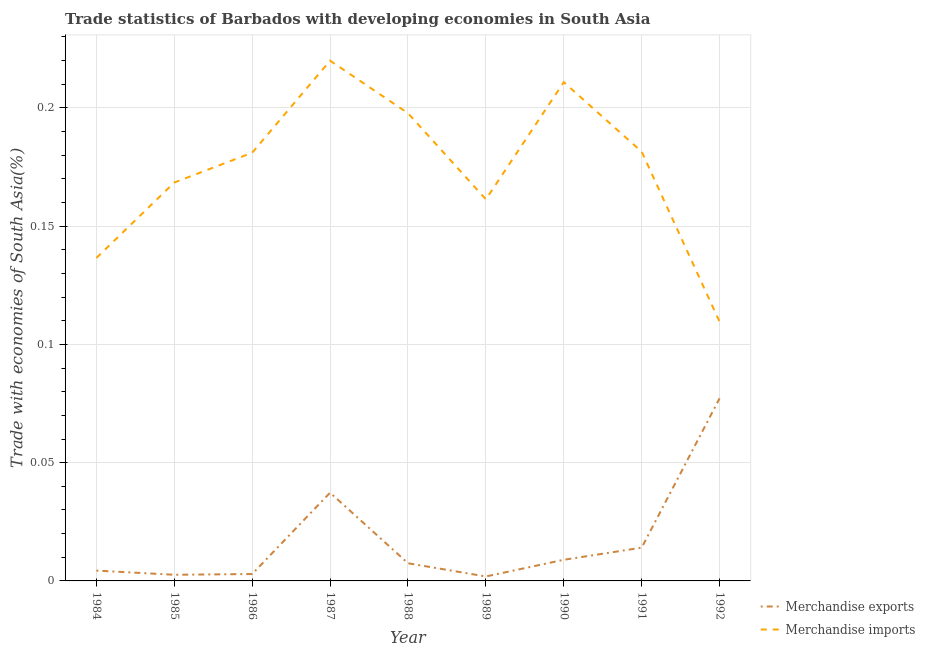How many different coloured lines are there?
Give a very brief answer. 2. Does the line corresponding to merchandise exports intersect with the line corresponding to merchandise imports?
Provide a succinct answer. No. What is the merchandise exports in 1992?
Provide a short and direct response. 0.08. Across all years, what is the maximum merchandise exports?
Make the answer very short. 0.08. Across all years, what is the minimum merchandise exports?
Ensure brevity in your answer.  0. In which year was the merchandise exports maximum?
Ensure brevity in your answer.  1992. In which year was the merchandise exports minimum?
Your answer should be compact. 1989. What is the total merchandise exports in the graph?
Offer a terse response. 0.16. What is the difference between the merchandise imports in 1984 and that in 1988?
Give a very brief answer. -0.06. What is the difference between the merchandise exports in 1991 and the merchandise imports in 1989?
Make the answer very short. -0.15. What is the average merchandise exports per year?
Provide a succinct answer. 0.02. In the year 1992, what is the difference between the merchandise imports and merchandise exports?
Keep it short and to the point. 0.03. What is the ratio of the merchandise exports in 1986 to that in 1990?
Provide a succinct answer. 0.33. Is the merchandise imports in 1985 less than that in 1991?
Offer a terse response. Yes. What is the difference between the highest and the second highest merchandise exports?
Keep it short and to the point. 0.04. What is the difference between the highest and the lowest merchandise exports?
Make the answer very short. 0.08. Is the sum of the merchandise imports in 1984 and 1985 greater than the maximum merchandise exports across all years?
Keep it short and to the point. Yes. Is the merchandise imports strictly greater than the merchandise exports over the years?
Provide a short and direct response. Yes. Is the merchandise exports strictly less than the merchandise imports over the years?
Your response must be concise. Yes. Are the values on the major ticks of Y-axis written in scientific E-notation?
Give a very brief answer. No. Does the graph contain any zero values?
Give a very brief answer. No. Does the graph contain grids?
Make the answer very short. Yes. Where does the legend appear in the graph?
Provide a short and direct response. Bottom right. How are the legend labels stacked?
Offer a terse response. Vertical. What is the title of the graph?
Provide a succinct answer. Trade statistics of Barbados with developing economies in South Asia. What is the label or title of the Y-axis?
Offer a very short reply. Trade with economies of South Asia(%). What is the Trade with economies of South Asia(%) in Merchandise exports in 1984?
Keep it short and to the point. 0. What is the Trade with economies of South Asia(%) in Merchandise imports in 1984?
Ensure brevity in your answer.  0.14. What is the Trade with economies of South Asia(%) in Merchandise exports in 1985?
Your answer should be compact. 0. What is the Trade with economies of South Asia(%) of Merchandise imports in 1985?
Your answer should be very brief. 0.17. What is the Trade with economies of South Asia(%) in Merchandise exports in 1986?
Offer a terse response. 0. What is the Trade with economies of South Asia(%) of Merchandise imports in 1986?
Offer a terse response. 0.18. What is the Trade with economies of South Asia(%) in Merchandise exports in 1987?
Your answer should be very brief. 0.04. What is the Trade with economies of South Asia(%) in Merchandise imports in 1987?
Ensure brevity in your answer.  0.22. What is the Trade with economies of South Asia(%) in Merchandise exports in 1988?
Provide a short and direct response. 0.01. What is the Trade with economies of South Asia(%) in Merchandise imports in 1988?
Keep it short and to the point. 0.2. What is the Trade with economies of South Asia(%) of Merchandise exports in 1989?
Offer a very short reply. 0. What is the Trade with economies of South Asia(%) of Merchandise imports in 1989?
Ensure brevity in your answer.  0.16. What is the Trade with economies of South Asia(%) of Merchandise exports in 1990?
Offer a very short reply. 0.01. What is the Trade with economies of South Asia(%) in Merchandise imports in 1990?
Offer a terse response. 0.21. What is the Trade with economies of South Asia(%) of Merchandise exports in 1991?
Provide a succinct answer. 0.01. What is the Trade with economies of South Asia(%) of Merchandise imports in 1991?
Keep it short and to the point. 0.18. What is the Trade with economies of South Asia(%) in Merchandise exports in 1992?
Your answer should be very brief. 0.08. What is the Trade with economies of South Asia(%) of Merchandise imports in 1992?
Give a very brief answer. 0.11. Across all years, what is the maximum Trade with economies of South Asia(%) in Merchandise exports?
Offer a terse response. 0.08. Across all years, what is the maximum Trade with economies of South Asia(%) in Merchandise imports?
Your answer should be compact. 0.22. Across all years, what is the minimum Trade with economies of South Asia(%) in Merchandise exports?
Offer a terse response. 0. Across all years, what is the minimum Trade with economies of South Asia(%) of Merchandise imports?
Your answer should be compact. 0.11. What is the total Trade with economies of South Asia(%) of Merchandise exports in the graph?
Keep it short and to the point. 0.16. What is the total Trade with economies of South Asia(%) of Merchandise imports in the graph?
Provide a succinct answer. 1.57. What is the difference between the Trade with economies of South Asia(%) in Merchandise exports in 1984 and that in 1985?
Ensure brevity in your answer.  0. What is the difference between the Trade with economies of South Asia(%) of Merchandise imports in 1984 and that in 1985?
Your answer should be compact. -0.03. What is the difference between the Trade with economies of South Asia(%) in Merchandise exports in 1984 and that in 1986?
Provide a succinct answer. 0. What is the difference between the Trade with economies of South Asia(%) of Merchandise imports in 1984 and that in 1986?
Your answer should be very brief. -0.04. What is the difference between the Trade with economies of South Asia(%) in Merchandise exports in 1984 and that in 1987?
Keep it short and to the point. -0.03. What is the difference between the Trade with economies of South Asia(%) of Merchandise imports in 1984 and that in 1987?
Make the answer very short. -0.08. What is the difference between the Trade with economies of South Asia(%) of Merchandise exports in 1984 and that in 1988?
Your response must be concise. -0. What is the difference between the Trade with economies of South Asia(%) in Merchandise imports in 1984 and that in 1988?
Offer a very short reply. -0.06. What is the difference between the Trade with economies of South Asia(%) of Merchandise exports in 1984 and that in 1989?
Your response must be concise. 0. What is the difference between the Trade with economies of South Asia(%) in Merchandise imports in 1984 and that in 1989?
Ensure brevity in your answer.  -0.02. What is the difference between the Trade with economies of South Asia(%) in Merchandise exports in 1984 and that in 1990?
Provide a short and direct response. -0. What is the difference between the Trade with economies of South Asia(%) in Merchandise imports in 1984 and that in 1990?
Offer a terse response. -0.07. What is the difference between the Trade with economies of South Asia(%) of Merchandise exports in 1984 and that in 1991?
Give a very brief answer. -0.01. What is the difference between the Trade with economies of South Asia(%) of Merchandise imports in 1984 and that in 1991?
Give a very brief answer. -0.04. What is the difference between the Trade with economies of South Asia(%) of Merchandise exports in 1984 and that in 1992?
Offer a terse response. -0.07. What is the difference between the Trade with economies of South Asia(%) in Merchandise imports in 1984 and that in 1992?
Your answer should be very brief. 0.03. What is the difference between the Trade with economies of South Asia(%) in Merchandise exports in 1985 and that in 1986?
Make the answer very short. -0. What is the difference between the Trade with economies of South Asia(%) of Merchandise imports in 1985 and that in 1986?
Provide a short and direct response. -0.01. What is the difference between the Trade with economies of South Asia(%) of Merchandise exports in 1985 and that in 1987?
Offer a terse response. -0.03. What is the difference between the Trade with economies of South Asia(%) in Merchandise imports in 1985 and that in 1987?
Your answer should be very brief. -0.05. What is the difference between the Trade with economies of South Asia(%) of Merchandise exports in 1985 and that in 1988?
Your answer should be very brief. -0. What is the difference between the Trade with economies of South Asia(%) in Merchandise imports in 1985 and that in 1988?
Keep it short and to the point. -0.03. What is the difference between the Trade with economies of South Asia(%) in Merchandise exports in 1985 and that in 1989?
Give a very brief answer. 0. What is the difference between the Trade with economies of South Asia(%) in Merchandise imports in 1985 and that in 1989?
Provide a short and direct response. 0.01. What is the difference between the Trade with economies of South Asia(%) in Merchandise exports in 1985 and that in 1990?
Provide a short and direct response. -0.01. What is the difference between the Trade with economies of South Asia(%) of Merchandise imports in 1985 and that in 1990?
Offer a terse response. -0.04. What is the difference between the Trade with economies of South Asia(%) in Merchandise exports in 1985 and that in 1991?
Your answer should be very brief. -0.01. What is the difference between the Trade with economies of South Asia(%) of Merchandise imports in 1985 and that in 1991?
Keep it short and to the point. -0.01. What is the difference between the Trade with economies of South Asia(%) in Merchandise exports in 1985 and that in 1992?
Keep it short and to the point. -0.07. What is the difference between the Trade with economies of South Asia(%) of Merchandise imports in 1985 and that in 1992?
Make the answer very short. 0.06. What is the difference between the Trade with economies of South Asia(%) of Merchandise exports in 1986 and that in 1987?
Offer a very short reply. -0.03. What is the difference between the Trade with economies of South Asia(%) of Merchandise imports in 1986 and that in 1987?
Provide a succinct answer. -0.04. What is the difference between the Trade with economies of South Asia(%) of Merchandise exports in 1986 and that in 1988?
Provide a short and direct response. -0. What is the difference between the Trade with economies of South Asia(%) of Merchandise imports in 1986 and that in 1988?
Give a very brief answer. -0.02. What is the difference between the Trade with economies of South Asia(%) of Merchandise imports in 1986 and that in 1989?
Provide a succinct answer. 0.02. What is the difference between the Trade with economies of South Asia(%) in Merchandise exports in 1986 and that in 1990?
Give a very brief answer. -0.01. What is the difference between the Trade with economies of South Asia(%) in Merchandise imports in 1986 and that in 1990?
Ensure brevity in your answer.  -0.03. What is the difference between the Trade with economies of South Asia(%) of Merchandise exports in 1986 and that in 1991?
Provide a short and direct response. -0.01. What is the difference between the Trade with economies of South Asia(%) of Merchandise imports in 1986 and that in 1991?
Your answer should be very brief. -0. What is the difference between the Trade with economies of South Asia(%) in Merchandise exports in 1986 and that in 1992?
Your answer should be compact. -0.07. What is the difference between the Trade with economies of South Asia(%) of Merchandise imports in 1986 and that in 1992?
Your answer should be very brief. 0.07. What is the difference between the Trade with economies of South Asia(%) of Merchandise exports in 1987 and that in 1988?
Provide a succinct answer. 0.03. What is the difference between the Trade with economies of South Asia(%) in Merchandise imports in 1987 and that in 1988?
Provide a short and direct response. 0.02. What is the difference between the Trade with economies of South Asia(%) of Merchandise exports in 1987 and that in 1989?
Make the answer very short. 0.04. What is the difference between the Trade with economies of South Asia(%) in Merchandise imports in 1987 and that in 1989?
Your answer should be very brief. 0.06. What is the difference between the Trade with economies of South Asia(%) of Merchandise exports in 1987 and that in 1990?
Your response must be concise. 0.03. What is the difference between the Trade with economies of South Asia(%) of Merchandise imports in 1987 and that in 1990?
Your response must be concise. 0.01. What is the difference between the Trade with economies of South Asia(%) in Merchandise exports in 1987 and that in 1991?
Your response must be concise. 0.02. What is the difference between the Trade with economies of South Asia(%) in Merchandise imports in 1987 and that in 1991?
Your response must be concise. 0.04. What is the difference between the Trade with economies of South Asia(%) of Merchandise exports in 1987 and that in 1992?
Provide a short and direct response. -0.04. What is the difference between the Trade with economies of South Asia(%) in Merchandise imports in 1987 and that in 1992?
Your response must be concise. 0.11. What is the difference between the Trade with economies of South Asia(%) in Merchandise exports in 1988 and that in 1989?
Provide a short and direct response. 0.01. What is the difference between the Trade with economies of South Asia(%) of Merchandise imports in 1988 and that in 1989?
Keep it short and to the point. 0.04. What is the difference between the Trade with economies of South Asia(%) in Merchandise exports in 1988 and that in 1990?
Provide a short and direct response. -0. What is the difference between the Trade with economies of South Asia(%) in Merchandise imports in 1988 and that in 1990?
Your response must be concise. -0.01. What is the difference between the Trade with economies of South Asia(%) of Merchandise exports in 1988 and that in 1991?
Your answer should be compact. -0.01. What is the difference between the Trade with economies of South Asia(%) in Merchandise imports in 1988 and that in 1991?
Provide a short and direct response. 0.02. What is the difference between the Trade with economies of South Asia(%) in Merchandise exports in 1988 and that in 1992?
Your response must be concise. -0.07. What is the difference between the Trade with economies of South Asia(%) in Merchandise imports in 1988 and that in 1992?
Provide a short and direct response. 0.09. What is the difference between the Trade with economies of South Asia(%) of Merchandise exports in 1989 and that in 1990?
Offer a terse response. -0.01. What is the difference between the Trade with economies of South Asia(%) in Merchandise imports in 1989 and that in 1990?
Give a very brief answer. -0.05. What is the difference between the Trade with economies of South Asia(%) in Merchandise exports in 1989 and that in 1991?
Offer a terse response. -0.01. What is the difference between the Trade with economies of South Asia(%) in Merchandise imports in 1989 and that in 1991?
Your answer should be very brief. -0.02. What is the difference between the Trade with economies of South Asia(%) of Merchandise exports in 1989 and that in 1992?
Your response must be concise. -0.08. What is the difference between the Trade with economies of South Asia(%) of Merchandise imports in 1989 and that in 1992?
Give a very brief answer. 0.05. What is the difference between the Trade with economies of South Asia(%) of Merchandise exports in 1990 and that in 1991?
Offer a very short reply. -0.01. What is the difference between the Trade with economies of South Asia(%) in Merchandise imports in 1990 and that in 1991?
Offer a terse response. 0.03. What is the difference between the Trade with economies of South Asia(%) in Merchandise exports in 1990 and that in 1992?
Your answer should be very brief. -0.07. What is the difference between the Trade with economies of South Asia(%) in Merchandise imports in 1990 and that in 1992?
Your answer should be very brief. 0.1. What is the difference between the Trade with economies of South Asia(%) of Merchandise exports in 1991 and that in 1992?
Ensure brevity in your answer.  -0.06. What is the difference between the Trade with economies of South Asia(%) of Merchandise imports in 1991 and that in 1992?
Offer a very short reply. 0.07. What is the difference between the Trade with economies of South Asia(%) in Merchandise exports in 1984 and the Trade with economies of South Asia(%) in Merchandise imports in 1985?
Make the answer very short. -0.16. What is the difference between the Trade with economies of South Asia(%) in Merchandise exports in 1984 and the Trade with economies of South Asia(%) in Merchandise imports in 1986?
Your answer should be compact. -0.18. What is the difference between the Trade with economies of South Asia(%) in Merchandise exports in 1984 and the Trade with economies of South Asia(%) in Merchandise imports in 1987?
Offer a terse response. -0.22. What is the difference between the Trade with economies of South Asia(%) in Merchandise exports in 1984 and the Trade with economies of South Asia(%) in Merchandise imports in 1988?
Your answer should be compact. -0.19. What is the difference between the Trade with economies of South Asia(%) of Merchandise exports in 1984 and the Trade with economies of South Asia(%) of Merchandise imports in 1989?
Keep it short and to the point. -0.16. What is the difference between the Trade with economies of South Asia(%) in Merchandise exports in 1984 and the Trade with economies of South Asia(%) in Merchandise imports in 1990?
Make the answer very short. -0.21. What is the difference between the Trade with economies of South Asia(%) in Merchandise exports in 1984 and the Trade with economies of South Asia(%) in Merchandise imports in 1991?
Make the answer very short. -0.18. What is the difference between the Trade with economies of South Asia(%) of Merchandise exports in 1984 and the Trade with economies of South Asia(%) of Merchandise imports in 1992?
Your answer should be compact. -0.11. What is the difference between the Trade with economies of South Asia(%) in Merchandise exports in 1985 and the Trade with economies of South Asia(%) in Merchandise imports in 1986?
Your response must be concise. -0.18. What is the difference between the Trade with economies of South Asia(%) in Merchandise exports in 1985 and the Trade with economies of South Asia(%) in Merchandise imports in 1987?
Provide a succinct answer. -0.22. What is the difference between the Trade with economies of South Asia(%) in Merchandise exports in 1985 and the Trade with economies of South Asia(%) in Merchandise imports in 1988?
Your answer should be compact. -0.2. What is the difference between the Trade with economies of South Asia(%) in Merchandise exports in 1985 and the Trade with economies of South Asia(%) in Merchandise imports in 1989?
Provide a succinct answer. -0.16. What is the difference between the Trade with economies of South Asia(%) in Merchandise exports in 1985 and the Trade with economies of South Asia(%) in Merchandise imports in 1990?
Make the answer very short. -0.21. What is the difference between the Trade with economies of South Asia(%) in Merchandise exports in 1985 and the Trade with economies of South Asia(%) in Merchandise imports in 1991?
Give a very brief answer. -0.18. What is the difference between the Trade with economies of South Asia(%) in Merchandise exports in 1985 and the Trade with economies of South Asia(%) in Merchandise imports in 1992?
Give a very brief answer. -0.11. What is the difference between the Trade with economies of South Asia(%) of Merchandise exports in 1986 and the Trade with economies of South Asia(%) of Merchandise imports in 1987?
Give a very brief answer. -0.22. What is the difference between the Trade with economies of South Asia(%) of Merchandise exports in 1986 and the Trade with economies of South Asia(%) of Merchandise imports in 1988?
Keep it short and to the point. -0.19. What is the difference between the Trade with economies of South Asia(%) of Merchandise exports in 1986 and the Trade with economies of South Asia(%) of Merchandise imports in 1989?
Offer a very short reply. -0.16. What is the difference between the Trade with economies of South Asia(%) of Merchandise exports in 1986 and the Trade with economies of South Asia(%) of Merchandise imports in 1990?
Your response must be concise. -0.21. What is the difference between the Trade with economies of South Asia(%) in Merchandise exports in 1986 and the Trade with economies of South Asia(%) in Merchandise imports in 1991?
Give a very brief answer. -0.18. What is the difference between the Trade with economies of South Asia(%) in Merchandise exports in 1986 and the Trade with economies of South Asia(%) in Merchandise imports in 1992?
Provide a short and direct response. -0.11. What is the difference between the Trade with economies of South Asia(%) of Merchandise exports in 1987 and the Trade with economies of South Asia(%) of Merchandise imports in 1988?
Your response must be concise. -0.16. What is the difference between the Trade with economies of South Asia(%) of Merchandise exports in 1987 and the Trade with economies of South Asia(%) of Merchandise imports in 1989?
Your response must be concise. -0.12. What is the difference between the Trade with economies of South Asia(%) in Merchandise exports in 1987 and the Trade with economies of South Asia(%) in Merchandise imports in 1990?
Keep it short and to the point. -0.17. What is the difference between the Trade with economies of South Asia(%) of Merchandise exports in 1987 and the Trade with economies of South Asia(%) of Merchandise imports in 1991?
Make the answer very short. -0.14. What is the difference between the Trade with economies of South Asia(%) in Merchandise exports in 1987 and the Trade with economies of South Asia(%) in Merchandise imports in 1992?
Keep it short and to the point. -0.07. What is the difference between the Trade with economies of South Asia(%) of Merchandise exports in 1988 and the Trade with economies of South Asia(%) of Merchandise imports in 1989?
Provide a short and direct response. -0.15. What is the difference between the Trade with economies of South Asia(%) in Merchandise exports in 1988 and the Trade with economies of South Asia(%) in Merchandise imports in 1990?
Your answer should be very brief. -0.2. What is the difference between the Trade with economies of South Asia(%) in Merchandise exports in 1988 and the Trade with economies of South Asia(%) in Merchandise imports in 1991?
Keep it short and to the point. -0.17. What is the difference between the Trade with economies of South Asia(%) in Merchandise exports in 1988 and the Trade with economies of South Asia(%) in Merchandise imports in 1992?
Ensure brevity in your answer.  -0.1. What is the difference between the Trade with economies of South Asia(%) in Merchandise exports in 1989 and the Trade with economies of South Asia(%) in Merchandise imports in 1990?
Provide a succinct answer. -0.21. What is the difference between the Trade with economies of South Asia(%) of Merchandise exports in 1989 and the Trade with economies of South Asia(%) of Merchandise imports in 1991?
Make the answer very short. -0.18. What is the difference between the Trade with economies of South Asia(%) of Merchandise exports in 1989 and the Trade with economies of South Asia(%) of Merchandise imports in 1992?
Keep it short and to the point. -0.11. What is the difference between the Trade with economies of South Asia(%) of Merchandise exports in 1990 and the Trade with economies of South Asia(%) of Merchandise imports in 1991?
Make the answer very short. -0.17. What is the difference between the Trade with economies of South Asia(%) in Merchandise exports in 1990 and the Trade with economies of South Asia(%) in Merchandise imports in 1992?
Ensure brevity in your answer.  -0.1. What is the difference between the Trade with economies of South Asia(%) in Merchandise exports in 1991 and the Trade with economies of South Asia(%) in Merchandise imports in 1992?
Give a very brief answer. -0.1. What is the average Trade with economies of South Asia(%) of Merchandise exports per year?
Keep it short and to the point. 0.02. What is the average Trade with economies of South Asia(%) of Merchandise imports per year?
Offer a very short reply. 0.17. In the year 1984, what is the difference between the Trade with economies of South Asia(%) of Merchandise exports and Trade with economies of South Asia(%) of Merchandise imports?
Offer a terse response. -0.13. In the year 1985, what is the difference between the Trade with economies of South Asia(%) in Merchandise exports and Trade with economies of South Asia(%) in Merchandise imports?
Ensure brevity in your answer.  -0.17. In the year 1986, what is the difference between the Trade with economies of South Asia(%) of Merchandise exports and Trade with economies of South Asia(%) of Merchandise imports?
Provide a short and direct response. -0.18. In the year 1987, what is the difference between the Trade with economies of South Asia(%) of Merchandise exports and Trade with economies of South Asia(%) of Merchandise imports?
Give a very brief answer. -0.18. In the year 1988, what is the difference between the Trade with economies of South Asia(%) of Merchandise exports and Trade with economies of South Asia(%) of Merchandise imports?
Provide a succinct answer. -0.19. In the year 1989, what is the difference between the Trade with economies of South Asia(%) in Merchandise exports and Trade with economies of South Asia(%) in Merchandise imports?
Your answer should be very brief. -0.16. In the year 1990, what is the difference between the Trade with economies of South Asia(%) in Merchandise exports and Trade with economies of South Asia(%) in Merchandise imports?
Give a very brief answer. -0.2. In the year 1991, what is the difference between the Trade with economies of South Asia(%) of Merchandise exports and Trade with economies of South Asia(%) of Merchandise imports?
Offer a terse response. -0.17. In the year 1992, what is the difference between the Trade with economies of South Asia(%) of Merchandise exports and Trade with economies of South Asia(%) of Merchandise imports?
Offer a terse response. -0.03. What is the ratio of the Trade with economies of South Asia(%) of Merchandise exports in 1984 to that in 1985?
Give a very brief answer. 1.68. What is the ratio of the Trade with economies of South Asia(%) in Merchandise imports in 1984 to that in 1985?
Offer a terse response. 0.81. What is the ratio of the Trade with economies of South Asia(%) of Merchandise exports in 1984 to that in 1986?
Keep it short and to the point. 1.49. What is the ratio of the Trade with economies of South Asia(%) of Merchandise imports in 1984 to that in 1986?
Provide a succinct answer. 0.75. What is the ratio of the Trade with economies of South Asia(%) in Merchandise exports in 1984 to that in 1987?
Ensure brevity in your answer.  0.12. What is the ratio of the Trade with economies of South Asia(%) in Merchandise imports in 1984 to that in 1987?
Provide a short and direct response. 0.62. What is the ratio of the Trade with economies of South Asia(%) of Merchandise exports in 1984 to that in 1988?
Provide a short and direct response. 0.58. What is the ratio of the Trade with economies of South Asia(%) in Merchandise imports in 1984 to that in 1988?
Provide a succinct answer. 0.69. What is the ratio of the Trade with economies of South Asia(%) in Merchandise exports in 1984 to that in 1989?
Your answer should be compact. 2.32. What is the ratio of the Trade with economies of South Asia(%) in Merchandise imports in 1984 to that in 1989?
Keep it short and to the point. 0.85. What is the ratio of the Trade with economies of South Asia(%) of Merchandise exports in 1984 to that in 1990?
Your answer should be compact. 0.49. What is the ratio of the Trade with economies of South Asia(%) of Merchandise imports in 1984 to that in 1990?
Make the answer very short. 0.65. What is the ratio of the Trade with economies of South Asia(%) of Merchandise exports in 1984 to that in 1991?
Your answer should be compact. 0.31. What is the ratio of the Trade with economies of South Asia(%) in Merchandise imports in 1984 to that in 1991?
Make the answer very short. 0.75. What is the ratio of the Trade with economies of South Asia(%) of Merchandise exports in 1984 to that in 1992?
Give a very brief answer. 0.06. What is the ratio of the Trade with economies of South Asia(%) of Merchandise imports in 1984 to that in 1992?
Ensure brevity in your answer.  1.25. What is the ratio of the Trade with economies of South Asia(%) in Merchandise exports in 1985 to that in 1986?
Provide a short and direct response. 0.89. What is the ratio of the Trade with economies of South Asia(%) in Merchandise imports in 1985 to that in 1986?
Offer a terse response. 0.93. What is the ratio of the Trade with economies of South Asia(%) in Merchandise exports in 1985 to that in 1987?
Your answer should be compact. 0.07. What is the ratio of the Trade with economies of South Asia(%) in Merchandise imports in 1985 to that in 1987?
Ensure brevity in your answer.  0.77. What is the ratio of the Trade with economies of South Asia(%) of Merchandise exports in 1985 to that in 1988?
Provide a succinct answer. 0.35. What is the ratio of the Trade with economies of South Asia(%) in Merchandise imports in 1985 to that in 1988?
Offer a terse response. 0.85. What is the ratio of the Trade with economies of South Asia(%) in Merchandise exports in 1985 to that in 1989?
Offer a terse response. 1.38. What is the ratio of the Trade with economies of South Asia(%) of Merchandise imports in 1985 to that in 1989?
Your response must be concise. 1.04. What is the ratio of the Trade with economies of South Asia(%) of Merchandise exports in 1985 to that in 1990?
Offer a terse response. 0.29. What is the ratio of the Trade with economies of South Asia(%) of Merchandise imports in 1985 to that in 1990?
Offer a terse response. 0.8. What is the ratio of the Trade with economies of South Asia(%) in Merchandise exports in 1985 to that in 1991?
Offer a terse response. 0.18. What is the ratio of the Trade with economies of South Asia(%) in Merchandise imports in 1985 to that in 1991?
Ensure brevity in your answer.  0.93. What is the ratio of the Trade with economies of South Asia(%) in Merchandise exports in 1985 to that in 1992?
Your answer should be very brief. 0.03. What is the ratio of the Trade with economies of South Asia(%) of Merchandise imports in 1985 to that in 1992?
Your answer should be compact. 1.54. What is the ratio of the Trade with economies of South Asia(%) of Merchandise exports in 1986 to that in 1987?
Your answer should be very brief. 0.08. What is the ratio of the Trade with economies of South Asia(%) of Merchandise imports in 1986 to that in 1987?
Your answer should be compact. 0.82. What is the ratio of the Trade with economies of South Asia(%) of Merchandise exports in 1986 to that in 1988?
Your response must be concise. 0.39. What is the ratio of the Trade with economies of South Asia(%) of Merchandise imports in 1986 to that in 1988?
Offer a terse response. 0.92. What is the ratio of the Trade with economies of South Asia(%) in Merchandise exports in 1986 to that in 1989?
Offer a very short reply. 1.55. What is the ratio of the Trade with economies of South Asia(%) in Merchandise imports in 1986 to that in 1989?
Your response must be concise. 1.12. What is the ratio of the Trade with economies of South Asia(%) of Merchandise exports in 1986 to that in 1990?
Your response must be concise. 0.33. What is the ratio of the Trade with economies of South Asia(%) of Merchandise imports in 1986 to that in 1990?
Your answer should be very brief. 0.86. What is the ratio of the Trade with economies of South Asia(%) in Merchandise exports in 1986 to that in 1991?
Give a very brief answer. 0.21. What is the ratio of the Trade with economies of South Asia(%) in Merchandise exports in 1986 to that in 1992?
Offer a very short reply. 0.04. What is the ratio of the Trade with economies of South Asia(%) in Merchandise imports in 1986 to that in 1992?
Your answer should be compact. 1.65. What is the ratio of the Trade with economies of South Asia(%) of Merchandise exports in 1987 to that in 1988?
Your response must be concise. 4.99. What is the ratio of the Trade with economies of South Asia(%) in Merchandise imports in 1987 to that in 1988?
Offer a terse response. 1.11. What is the ratio of the Trade with economies of South Asia(%) in Merchandise exports in 1987 to that in 1989?
Your answer should be very brief. 19.84. What is the ratio of the Trade with economies of South Asia(%) in Merchandise imports in 1987 to that in 1989?
Provide a short and direct response. 1.36. What is the ratio of the Trade with economies of South Asia(%) of Merchandise exports in 1987 to that in 1990?
Give a very brief answer. 4.18. What is the ratio of the Trade with economies of South Asia(%) in Merchandise imports in 1987 to that in 1990?
Your response must be concise. 1.04. What is the ratio of the Trade with economies of South Asia(%) in Merchandise exports in 1987 to that in 1991?
Your response must be concise. 2.65. What is the ratio of the Trade with economies of South Asia(%) in Merchandise imports in 1987 to that in 1991?
Make the answer very short. 1.21. What is the ratio of the Trade with economies of South Asia(%) in Merchandise exports in 1987 to that in 1992?
Give a very brief answer. 0.48. What is the ratio of the Trade with economies of South Asia(%) of Merchandise imports in 1987 to that in 1992?
Make the answer very short. 2.01. What is the ratio of the Trade with economies of South Asia(%) in Merchandise exports in 1988 to that in 1989?
Offer a very short reply. 3.97. What is the ratio of the Trade with economies of South Asia(%) of Merchandise imports in 1988 to that in 1989?
Provide a succinct answer. 1.23. What is the ratio of the Trade with economies of South Asia(%) in Merchandise exports in 1988 to that in 1990?
Your response must be concise. 0.84. What is the ratio of the Trade with economies of South Asia(%) of Merchandise imports in 1988 to that in 1990?
Ensure brevity in your answer.  0.94. What is the ratio of the Trade with economies of South Asia(%) of Merchandise exports in 1988 to that in 1991?
Provide a succinct answer. 0.53. What is the ratio of the Trade with economies of South Asia(%) of Merchandise imports in 1988 to that in 1991?
Your response must be concise. 1.09. What is the ratio of the Trade with economies of South Asia(%) in Merchandise exports in 1988 to that in 1992?
Offer a terse response. 0.1. What is the ratio of the Trade with economies of South Asia(%) of Merchandise imports in 1988 to that in 1992?
Your response must be concise. 1.8. What is the ratio of the Trade with economies of South Asia(%) of Merchandise exports in 1989 to that in 1990?
Offer a very short reply. 0.21. What is the ratio of the Trade with economies of South Asia(%) in Merchandise imports in 1989 to that in 1990?
Keep it short and to the point. 0.77. What is the ratio of the Trade with economies of South Asia(%) in Merchandise exports in 1989 to that in 1991?
Offer a very short reply. 0.13. What is the ratio of the Trade with economies of South Asia(%) of Merchandise exports in 1989 to that in 1992?
Make the answer very short. 0.02. What is the ratio of the Trade with economies of South Asia(%) of Merchandise imports in 1989 to that in 1992?
Keep it short and to the point. 1.47. What is the ratio of the Trade with economies of South Asia(%) in Merchandise exports in 1990 to that in 1991?
Your response must be concise. 0.64. What is the ratio of the Trade with economies of South Asia(%) in Merchandise imports in 1990 to that in 1991?
Give a very brief answer. 1.16. What is the ratio of the Trade with economies of South Asia(%) of Merchandise exports in 1990 to that in 1992?
Provide a short and direct response. 0.12. What is the ratio of the Trade with economies of South Asia(%) in Merchandise imports in 1990 to that in 1992?
Provide a short and direct response. 1.92. What is the ratio of the Trade with economies of South Asia(%) in Merchandise exports in 1991 to that in 1992?
Ensure brevity in your answer.  0.18. What is the ratio of the Trade with economies of South Asia(%) of Merchandise imports in 1991 to that in 1992?
Offer a very short reply. 1.66. What is the difference between the highest and the second highest Trade with economies of South Asia(%) in Merchandise exports?
Make the answer very short. 0.04. What is the difference between the highest and the second highest Trade with economies of South Asia(%) of Merchandise imports?
Your answer should be very brief. 0.01. What is the difference between the highest and the lowest Trade with economies of South Asia(%) in Merchandise exports?
Your response must be concise. 0.08. What is the difference between the highest and the lowest Trade with economies of South Asia(%) of Merchandise imports?
Offer a very short reply. 0.11. 